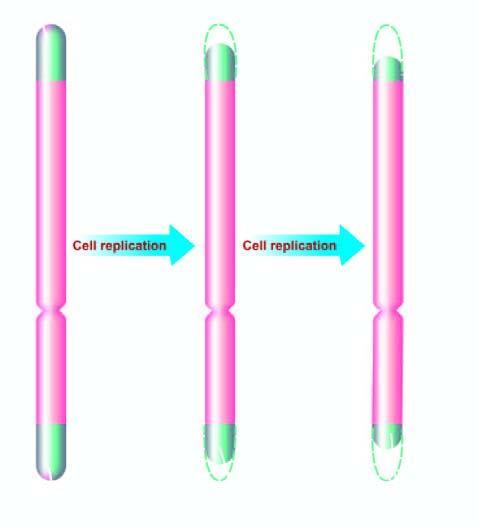what are progressively shortened in aging?
Answer the question using a single word or phrase. These end components of chromosome 